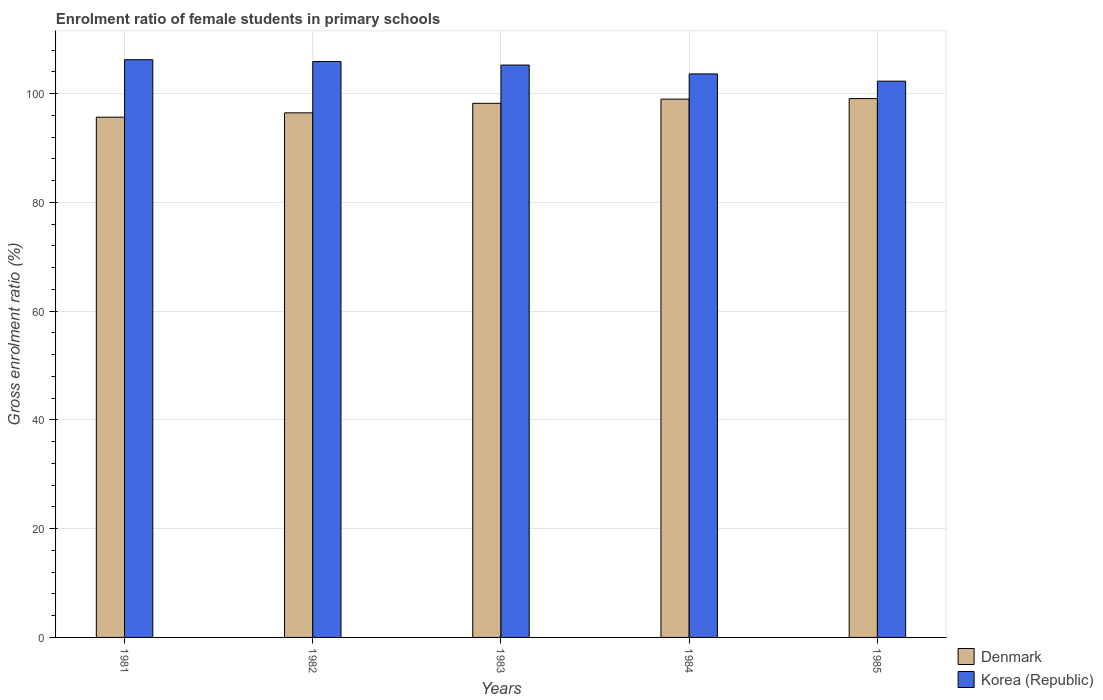How many bars are there on the 1st tick from the left?
Make the answer very short. 2. How many bars are there on the 1st tick from the right?
Your response must be concise. 2. What is the label of the 4th group of bars from the left?
Offer a very short reply. 1984. What is the enrolment ratio of female students in primary schools in Denmark in 1983?
Provide a short and direct response. 98.21. Across all years, what is the maximum enrolment ratio of female students in primary schools in Denmark?
Provide a succinct answer. 99.08. Across all years, what is the minimum enrolment ratio of female students in primary schools in Korea (Republic)?
Your answer should be very brief. 102.29. What is the total enrolment ratio of female students in primary schools in Denmark in the graph?
Give a very brief answer. 488.38. What is the difference between the enrolment ratio of female students in primary schools in Denmark in 1984 and that in 1985?
Your answer should be compact. -0.1. What is the difference between the enrolment ratio of female students in primary schools in Denmark in 1983 and the enrolment ratio of female students in primary schools in Korea (Republic) in 1984?
Keep it short and to the point. -5.41. What is the average enrolment ratio of female students in primary schools in Denmark per year?
Give a very brief answer. 97.68. In the year 1983, what is the difference between the enrolment ratio of female students in primary schools in Korea (Republic) and enrolment ratio of female students in primary schools in Denmark?
Your response must be concise. 7.04. In how many years, is the enrolment ratio of female students in primary schools in Denmark greater than 28 %?
Provide a short and direct response. 5. What is the ratio of the enrolment ratio of female students in primary schools in Denmark in 1981 to that in 1982?
Ensure brevity in your answer.  0.99. What is the difference between the highest and the second highest enrolment ratio of female students in primary schools in Korea (Republic)?
Provide a short and direct response. 0.33. What is the difference between the highest and the lowest enrolment ratio of female students in primary schools in Denmark?
Provide a short and direct response. 3.42. In how many years, is the enrolment ratio of female students in primary schools in Korea (Republic) greater than the average enrolment ratio of female students in primary schools in Korea (Republic) taken over all years?
Offer a very short reply. 3. Is the sum of the enrolment ratio of female students in primary schools in Denmark in 1983 and 1985 greater than the maximum enrolment ratio of female students in primary schools in Korea (Republic) across all years?
Your answer should be compact. Yes. What does the 1st bar from the right in 1983 represents?
Your answer should be very brief. Korea (Republic). How many bars are there?
Keep it short and to the point. 10. How many years are there in the graph?
Ensure brevity in your answer.  5. What is the difference between two consecutive major ticks on the Y-axis?
Keep it short and to the point. 20. Does the graph contain any zero values?
Your response must be concise. No. Does the graph contain grids?
Make the answer very short. Yes. How are the legend labels stacked?
Keep it short and to the point. Vertical. What is the title of the graph?
Offer a terse response. Enrolment ratio of female students in primary schools. What is the label or title of the Y-axis?
Ensure brevity in your answer.  Gross enrolment ratio (%). What is the Gross enrolment ratio (%) in Denmark in 1981?
Keep it short and to the point. 95.66. What is the Gross enrolment ratio (%) in Korea (Republic) in 1981?
Keep it short and to the point. 106.23. What is the Gross enrolment ratio (%) of Denmark in 1982?
Offer a terse response. 96.46. What is the Gross enrolment ratio (%) in Korea (Republic) in 1982?
Give a very brief answer. 105.9. What is the Gross enrolment ratio (%) in Denmark in 1983?
Ensure brevity in your answer.  98.21. What is the Gross enrolment ratio (%) of Korea (Republic) in 1983?
Provide a short and direct response. 105.25. What is the Gross enrolment ratio (%) in Denmark in 1984?
Your answer should be compact. 98.98. What is the Gross enrolment ratio (%) in Korea (Republic) in 1984?
Your response must be concise. 103.61. What is the Gross enrolment ratio (%) in Denmark in 1985?
Offer a very short reply. 99.08. What is the Gross enrolment ratio (%) of Korea (Republic) in 1985?
Make the answer very short. 102.29. Across all years, what is the maximum Gross enrolment ratio (%) of Denmark?
Give a very brief answer. 99.08. Across all years, what is the maximum Gross enrolment ratio (%) in Korea (Republic)?
Provide a short and direct response. 106.23. Across all years, what is the minimum Gross enrolment ratio (%) of Denmark?
Offer a very short reply. 95.66. Across all years, what is the minimum Gross enrolment ratio (%) in Korea (Republic)?
Offer a very short reply. 102.29. What is the total Gross enrolment ratio (%) of Denmark in the graph?
Provide a short and direct response. 488.38. What is the total Gross enrolment ratio (%) in Korea (Republic) in the graph?
Offer a terse response. 523.27. What is the difference between the Gross enrolment ratio (%) of Denmark in 1981 and that in 1982?
Make the answer very short. -0.8. What is the difference between the Gross enrolment ratio (%) of Korea (Republic) in 1981 and that in 1982?
Give a very brief answer. 0.33. What is the difference between the Gross enrolment ratio (%) of Denmark in 1981 and that in 1983?
Your response must be concise. -2.55. What is the difference between the Gross enrolment ratio (%) of Korea (Republic) in 1981 and that in 1983?
Your answer should be compact. 0.98. What is the difference between the Gross enrolment ratio (%) of Denmark in 1981 and that in 1984?
Provide a succinct answer. -3.32. What is the difference between the Gross enrolment ratio (%) of Korea (Republic) in 1981 and that in 1984?
Your answer should be very brief. 2.61. What is the difference between the Gross enrolment ratio (%) in Denmark in 1981 and that in 1985?
Give a very brief answer. -3.42. What is the difference between the Gross enrolment ratio (%) in Korea (Republic) in 1981 and that in 1985?
Provide a short and direct response. 3.94. What is the difference between the Gross enrolment ratio (%) in Denmark in 1982 and that in 1983?
Your response must be concise. -1.75. What is the difference between the Gross enrolment ratio (%) in Korea (Republic) in 1982 and that in 1983?
Make the answer very short. 0.65. What is the difference between the Gross enrolment ratio (%) in Denmark in 1982 and that in 1984?
Offer a terse response. -2.52. What is the difference between the Gross enrolment ratio (%) of Korea (Republic) in 1982 and that in 1984?
Keep it short and to the point. 2.28. What is the difference between the Gross enrolment ratio (%) of Denmark in 1982 and that in 1985?
Make the answer very short. -2.62. What is the difference between the Gross enrolment ratio (%) of Korea (Republic) in 1982 and that in 1985?
Ensure brevity in your answer.  3.61. What is the difference between the Gross enrolment ratio (%) in Denmark in 1983 and that in 1984?
Make the answer very short. -0.77. What is the difference between the Gross enrolment ratio (%) in Korea (Republic) in 1983 and that in 1984?
Your response must be concise. 1.63. What is the difference between the Gross enrolment ratio (%) of Denmark in 1983 and that in 1985?
Ensure brevity in your answer.  -0.87. What is the difference between the Gross enrolment ratio (%) of Korea (Republic) in 1983 and that in 1985?
Your response must be concise. 2.96. What is the difference between the Gross enrolment ratio (%) in Denmark in 1984 and that in 1985?
Your answer should be compact. -0.1. What is the difference between the Gross enrolment ratio (%) of Korea (Republic) in 1984 and that in 1985?
Offer a very short reply. 1.33. What is the difference between the Gross enrolment ratio (%) of Denmark in 1981 and the Gross enrolment ratio (%) of Korea (Republic) in 1982?
Your answer should be very brief. -10.24. What is the difference between the Gross enrolment ratio (%) of Denmark in 1981 and the Gross enrolment ratio (%) of Korea (Republic) in 1983?
Ensure brevity in your answer.  -9.59. What is the difference between the Gross enrolment ratio (%) in Denmark in 1981 and the Gross enrolment ratio (%) in Korea (Republic) in 1984?
Make the answer very short. -7.96. What is the difference between the Gross enrolment ratio (%) of Denmark in 1981 and the Gross enrolment ratio (%) of Korea (Republic) in 1985?
Ensure brevity in your answer.  -6.63. What is the difference between the Gross enrolment ratio (%) of Denmark in 1982 and the Gross enrolment ratio (%) of Korea (Republic) in 1983?
Provide a succinct answer. -8.79. What is the difference between the Gross enrolment ratio (%) in Denmark in 1982 and the Gross enrolment ratio (%) in Korea (Republic) in 1984?
Keep it short and to the point. -7.16. What is the difference between the Gross enrolment ratio (%) in Denmark in 1982 and the Gross enrolment ratio (%) in Korea (Republic) in 1985?
Your answer should be very brief. -5.83. What is the difference between the Gross enrolment ratio (%) of Denmark in 1983 and the Gross enrolment ratio (%) of Korea (Republic) in 1984?
Offer a terse response. -5.41. What is the difference between the Gross enrolment ratio (%) of Denmark in 1983 and the Gross enrolment ratio (%) of Korea (Republic) in 1985?
Provide a succinct answer. -4.08. What is the difference between the Gross enrolment ratio (%) of Denmark in 1984 and the Gross enrolment ratio (%) of Korea (Republic) in 1985?
Provide a short and direct response. -3.31. What is the average Gross enrolment ratio (%) in Denmark per year?
Your answer should be very brief. 97.68. What is the average Gross enrolment ratio (%) of Korea (Republic) per year?
Give a very brief answer. 104.65. In the year 1981, what is the difference between the Gross enrolment ratio (%) of Denmark and Gross enrolment ratio (%) of Korea (Republic)?
Provide a succinct answer. -10.57. In the year 1982, what is the difference between the Gross enrolment ratio (%) of Denmark and Gross enrolment ratio (%) of Korea (Republic)?
Your answer should be very brief. -9.44. In the year 1983, what is the difference between the Gross enrolment ratio (%) of Denmark and Gross enrolment ratio (%) of Korea (Republic)?
Offer a terse response. -7.04. In the year 1984, what is the difference between the Gross enrolment ratio (%) of Denmark and Gross enrolment ratio (%) of Korea (Republic)?
Make the answer very short. -4.64. In the year 1985, what is the difference between the Gross enrolment ratio (%) in Denmark and Gross enrolment ratio (%) in Korea (Republic)?
Provide a short and direct response. -3.21. What is the ratio of the Gross enrolment ratio (%) of Korea (Republic) in 1981 to that in 1982?
Offer a terse response. 1. What is the ratio of the Gross enrolment ratio (%) in Korea (Republic) in 1981 to that in 1983?
Your answer should be compact. 1.01. What is the ratio of the Gross enrolment ratio (%) of Denmark in 1981 to that in 1984?
Ensure brevity in your answer.  0.97. What is the ratio of the Gross enrolment ratio (%) in Korea (Republic) in 1981 to that in 1984?
Make the answer very short. 1.03. What is the ratio of the Gross enrolment ratio (%) of Denmark in 1981 to that in 1985?
Make the answer very short. 0.97. What is the ratio of the Gross enrolment ratio (%) in Korea (Republic) in 1981 to that in 1985?
Make the answer very short. 1.04. What is the ratio of the Gross enrolment ratio (%) of Denmark in 1982 to that in 1983?
Offer a terse response. 0.98. What is the ratio of the Gross enrolment ratio (%) of Denmark in 1982 to that in 1984?
Offer a terse response. 0.97. What is the ratio of the Gross enrolment ratio (%) in Denmark in 1982 to that in 1985?
Offer a terse response. 0.97. What is the ratio of the Gross enrolment ratio (%) in Korea (Republic) in 1982 to that in 1985?
Offer a terse response. 1.04. What is the ratio of the Gross enrolment ratio (%) of Korea (Republic) in 1983 to that in 1984?
Ensure brevity in your answer.  1.02. What is the ratio of the Gross enrolment ratio (%) in Denmark in 1983 to that in 1985?
Keep it short and to the point. 0.99. What is the ratio of the Gross enrolment ratio (%) of Korea (Republic) in 1983 to that in 1985?
Your answer should be very brief. 1.03. What is the ratio of the Gross enrolment ratio (%) of Korea (Republic) in 1984 to that in 1985?
Your answer should be very brief. 1.01. What is the difference between the highest and the second highest Gross enrolment ratio (%) of Denmark?
Offer a terse response. 0.1. What is the difference between the highest and the second highest Gross enrolment ratio (%) of Korea (Republic)?
Give a very brief answer. 0.33. What is the difference between the highest and the lowest Gross enrolment ratio (%) in Denmark?
Your answer should be compact. 3.42. What is the difference between the highest and the lowest Gross enrolment ratio (%) in Korea (Republic)?
Make the answer very short. 3.94. 